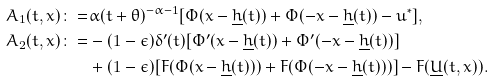<formula> <loc_0><loc_0><loc_500><loc_500>A _ { 1 } ( t , x ) \colon = & \alpha ( t + \theta ) ^ { - \alpha - 1 } [ \Phi ( x - \underline { h } ( t ) ) + \Phi ( - x - \underline { h } ( t ) ) - u ^ { * } ] , \\ A _ { 2 } ( t , x ) \colon = & - ( 1 - \epsilon ) \delta ^ { \prime } ( t ) [ \Phi ^ { \prime } ( x - \underline { h } ( t ) ) + \Phi ^ { \prime } ( - x - \underline { h } ( t ) ) ] \\ & + ( 1 - \epsilon ) [ F ( \Phi ( x - \underline { h } ( t ) ) ) + F ( \Phi ( - x - \underline { h } ( t ) ) ) ] - F ( \underline { U } ( t , x ) ) .</formula> 